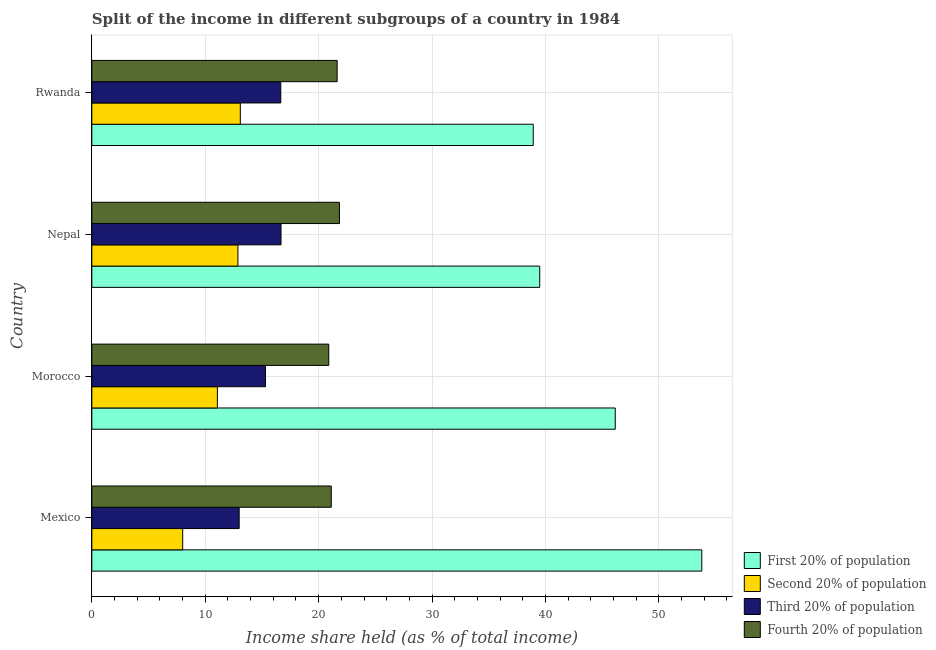Are the number of bars on each tick of the Y-axis equal?
Provide a short and direct response. Yes. How many bars are there on the 4th tick from the top?
Provide a succinct answer. 4. How many bars are there on the 2nd tick from the bottom?
Make the answer very short. 4. What is the label of the 1st group of bars from the top?
Give a very brief answer. Rwanda. In how many cases, is the number of bars for a given country not equal to the number of legend labels?
Offer a very short reply. 0. What is the share of the income held by third 20% of the population in Morocco?
Your answer should be compact. 15.31. Across all countries, what is the maximum share of the income held by second 20% of the population?
Keep it short and to the point. 13.09. Across all countries, what is the minimum share of the income held by third 20% of the population?
Provide a succinct answer. 12.99. In which country was the share of the income held by fourth 20% of the population maximum?
Your answer should be very brief. Nepal. What is the total share of the income held by fourth 20% of the population in the graph?
Offer a terse response. 85.46. What is the difference between the share of the income held by fourth 20% of the population in Mexico and that in Morocco?
Your answer should be very brief. 0.22. What is the difference between the share of the income held by third 20% of the population in Mexico and the share of the income held by first 20% of the population in Rwanda?
Offer a terse response. -25.93. What is the average share of the income held by second 20% of the population per country?
Make the answer very short. 11.26. What is the difference between the share of the income held by third 20% of the population and share of the income held by first 20% of the population in Mexico?
Offer a terse response. -40.79. What is the ratio of the share of the income held by fourth 20% of the population in Mexico to that in Nepal?
Offer a terse response. 0.97. What is the difference between the highest and the second highest share of the income held by second 20% of the population?
Your answer should be compact. 0.21. What is the difference between the highest and the lowest share of the income held by first 20% of the population?
Ensure brevity in your answer.  14.86. In how many countries, is the share of the income held by fourth 20% of the population greater than the average share of the income held by fourth 20% of the population taken over all countries?
Provide a succinct answer. 2. Is it the case that in every country, the sum of the share of the income held by third 20% of the population and share of the income held by second 20% of the population is greater than the sum of share of the income held by first 20% of the population and share of the income held by fourth 20% of the population?
Your answer should be compact. No. What does the 2nd bar from the top in Rwanda represents?
Provide a short and direct response. Third 20% of population. What does the 4th bar from the bottom in Mexico represents?
Your answer should be compact. Fourth 20% of population. Is it the case that in every country, the sum of the share of the income held by first 20% of the population and share of the income held by second 20% of the population is greater than the share of the income held by third 20% of the population?
Give a very brief answer. Yes. Are all the bars in the graph horizontal?
Your answer should be very brief. Yes. What is the difference between two consecutive major ticks on the X-axis?
Offer a very short reply. 10. Are the values on the major ticks of X-axis written in scientific E-notation?
Make the answer very short. No. Does the graph contain any zero values?
Give a very brief answer. No. Where does the legend appear in the graph?
Make the answer very short. Bottom right. How many legend labels are there?
Keep it short and to the point. 4. What is the title of the graph?
Make the answer very short. Split of the income in different subgroups of a country in 1984. What is the label or title of the X-axis?
Your answer should be very brief. Income share held (as % of total income). What is the label or title of the Y-axis?
Provide a short and direct response. Country. What is the Income share held (as % of total income) of First 20% of population in Mexico?
Your answer should be very brief. 53.78. What is the Income share held (as % of total income) in Second 20% of population in Mexico?
Provide a succinct answer. 8.01. What is the Income share held (as % of total income) of Third 20% of population in Mexico?
Keep it short and to the point. 12.99. What is the Income share held (as % of total income) in Fourth 20% of population in Mexico?
Provide a short and direct response. 21.11. What is the Income share held (as % of total income) of First 20% of population in Morocco?
Keep it short and to the point. 46.15. What is the Income share held (as % of total income) in Second 20% of population in Morocco?
Provide a succinct answer. 11.07. What is the Income share held (as % of total income) of Third 20% of population in Morocco?
Your response must be concise. 15.31. What is the Income share held (as % of total income) in Fourth 20% of population in Morocco?
Offer a terse response. 20.89. What is the Income share held (as % of total income) in First 20% of population in Nepal?
Provide a succinct answer. 39.49. What is the Income share held (as % of total income) in Second 20% of population in Nepal?
Your answer should be very brief. 12.88. What is the Income share held (as % of total income) of Third 20% of population in Nepal?
Offer a terse response. 16.68. What is the Income share held (as % of total income) in Fourth 20% of population in Nepal?
Provide a short and direct response. 21.83. What is the Income share held (as % of total income) in First 20% of population in Rwanda?
Your response must be concise. 38.92. What is the Income share held (as % of total income) in Second 20% of population in Rwanda?
Make the answer very short. 13.09. What is the Income share held (as % of total income) in Third 20% of population in Rwanda?
Keep it short and to the point. 16.66. What is the Income share held (as % of total income) of Fourth 20% of population in Rwanda?
Ensure brevity in your answer.  21.63. Across all countries, what is the maximum Income share held (as % of total income) of First 20% of population?
Your response must be concise. 53.78. Across all countries, what is the maximum Income share held (as % of total income) of Second 20% of population?
Offer a very short reply. 13.09. Across all countries, what is the maximum Income share held (as % of total income) of Third 20% of population?
Your answer should be very brief. 16.68. Across all countries, what is the maximum Income share held (as % of total income) in Fourth 20% of population?
Give a very brief answer. 21.83. Across all countries, what is the minimum Income share held (as % of total income) of First 20% of population?
Provide a short and direct response. 38.92. Across all countries, what is the minimum Income share held (as % of total income) in Second 20% of population?
Your answer should be very brief. 8.01. Across all countries, what is the minimum Income share held (as % of total income) of Third 20% of population?
Make the answer very short. 12.99. Across all countries, what is the minimum Income share held (as % of total income) of Fourth 20% of population?
Your answer should be compact. 20.89. What is the total Income share held (as % of total income) of First 20% of population in the graph?
Provide a short and direct response. 178.34. What is the total Income share held (as % of total income) of Second 20% of population in the graph?
Offer a very short reply. 45.05. What is the total Income share held (as % of total income) of Third 20% of population in the graph?
Your answer should be very brief. 61.64. What is the total Income share held (as % of total income) in Fourth 20% of population in the graph?
Ensure brevity in your answer.  85.46. What is the difference between the Income share held (as % of total income) of First 20% of population in Mexico and that in Morocco?
Offer a terse response. 7.63. What is the difference between the Income share held (as % of total income) in Second 20% of population in Mexico and that in Morocco?
Provide a succinct answer. -3.06. What is the difference between the Income share held (as % of total income) of Third 20% of population in Mexico and that in Morocco?
Make the answer very short. -2.32. What is the difference between the Income share held (as % of total income) of Fourth 20% of population in Mexico and that in Morocco?
Make the answer very short. 0.22. What is the difference between the Income share held (as % of total income) of First 20% of population in Mexico and that in Nepal?
Ensure brevity in your answer.  14.29. What is the difference between the Income share held (as % of total income) in Second 20% of population in Mexico and that in Nepal?
Offer a very short reply. -4.87. What is the difference between the Income share held (as % of total income) in Third 20% of population in Mexico and that in Nepal?
Your answer should be very brief. -3.69. What is the difference between the Income share held (as % of total income) of Fourth 20% of population in Mexico and that in Nepal?
Give a very brief answer. -0.72. What is the difference between the Income share held (as % of total income) of First 20% of population in Mexico and that in Rwanda?
Keep it short and to the point. 14.86. What is the difference between the Income share held (as % of total income) of Second 20% of population in Mexico and that in Rwanda?
Offer a very short reply. -5.08. What is the difference between the Income share held (as % of total income) in Third 20% of population in Mexico and that in Rwanda?
Offer a very short reply. -3.67. What is the difference between the Income share held (as % of total income) in Fourth 20% of population in Mexico and that in Rwanda?
Keep it short and to the point. -0.52. What is the difference between the Income share held (as % of total income) in First 20% of population in Morocco and that in Nepal?
Offer a terse response. 6.66. What is the difference between the Income share held (as % of total income) in Second 20% of population in Morocco and that in Nepal?
Make the answer very short. -1.81. What is the difference between the Income share held (as % of total income) in Third 20% of population in Morocco and that in Nepal?
Your answer should be very brief. -1.37. What is the difference between the Income share held (as % of total income) in Fourth 20% of population in Morocco and that in Nepal?
Give a very brief answer. -0.94. What is the difference between the Income share held (as % of total income) in First 20% of population in Morocco and that in Rwanda?
Make the answer very short. 7.23. What is the difference between the Income share held (as % of total income) in Second 20% of population in Morocco and that in Rwanda?
Your response must be concise. -2.02. What is the difference between the Income share held (as % of total income) of Third 20% of population in Morocco and that in Rwanda?
Keep it short and to the point. -1.35. What is the difference between the Income share held (as % of total income) of Fourth 20% of population in Morocco and that in Rwanda?
Offer a terse response. -0.74. What is the difference between the Income share held (as % of total income) in First 20% of population in Nepal and that in Rwanda?
Offer a terse response. 0.57. What is the difference between the Income share held (as % of total income) in Second 20% of population in Nepal and that in Rwanda?
Make the answer very short. -0.21. What is the difference between the Income share held (as % of total income) in Third 20% of population in Nepal and that in Rwanda?
Offer a terse response. 0.02. What is the difference between the Income share held (as % of total income) in First 20% of population in Mexico and the Income share held (as % of total income) in Second 20% of population in Morocco?
Keep it short and to the point. 42.71. What is the difference between the Income share held (as % of total income) of First 20% of population in Mexico and the Income share held (as % of total income) of Third 20% of population in Morocco?
Offer a very short reply. 38.47. What is the difference between the Income share held (as % of total income) in First 20% of population in Mexico and the Income share held (as % of total income) in Fourth 20% of population in Morocco?
Offer a terse response. 32.89. What is the difference between the Income share held (as % of total income) of Second 20% of population in Mexico and the Income share held (as % of total income) of Third 20% of population in Morocco?
Your answer should be very brief. -7.3. What is the difference between the Income share held (as % of total income) in Second 20% of population in Mexico and the Income share held (as % of total income) in Fourth 20% of population in Morocco?
Offer a terse response. -12.88. What is the difference between the Income share held (as % of total income) in Third 20% of population in Mexico and the Income share held (as % of total income) in Fourth 20% of population in Morocco?
Your answer should be very brief. -7.9. What is the difference between the Income share held (as % of total income) in First 20% of population in Mexico and the Income share held (as % of total income) in Second 20% of population in Nepal?
Keep it short and to the point. 40.9. What is the difference between the Income share held (as % of total income) in First 20% of population in Mexico and the Income share held (as % of total income) in Third 20% of population in Nepal?
Provide a short and direct response. 37.1. What is the difference between the Income share held (as % of total income) of First 20% of population in Mexico and the Income share held (as % of total income) of Fourth 20% of population in Nepal?
Your response must be concise. 31.95. What is the difference between the Income share held (as % of total income) of Second 20% of population in Mexico and the Income share held (as % of total income) of Third 20% of population in Nepal?
Provide a short and direct response. -8.67. What is the difference between the Income share held (as % of total income) in Second 20% of population in Mexico and the Income share held (as % of total income) in Fourth 20% of population in Nepal?
Make the answer very short. -13.82. What is the difference between the Income share held (as % of total income) of Third 20% of population in Mexico and the Income share held (as % of total income) of Fourth 20% of population in Nepal?
Offer a very short reply. -8.84. What is the difference between the Income share held (as % of total income) of First 20% of population in Mexico and the Income share held (as % of total income) of Second 20% of population in Rwanda?
Give a very brief answer. 40.69. What is the difference between the Income share held (as % of total income) in First 20% of population in Mexico and the Income share held (as % of total income) in Third 20% of population in Rwanda?
Your answer should be compact. 37.12. What is the difference between the Income share held (as % of total income) in First 20% of population in Mexico and the Income share held (as % of total income) in Fourth 20% of population in Rwanda?
Provide a succinct answer. 32.15. What is the difference between the Income share held (as % of total income) in Second 20% of population in Mexico and the Income share held (as % of total income) in Third 20% of population in Rwanda?
Make the answer very short. -8.65. What is the difference between the Income share held (as % of total income) of Second 20% of population in Mexico and the Income share held (as % of total income) of Fourth 20% of population in Rwanda?
Your answer should be compact. -13.62. What is the difference between the Income share held (as % of total income) in Third 20% of population in Mexico and the Income share held (as % of total income) in Fourth 20% of population in Rwanda?
Give a very brief answer. -8.64. What is the difference between the Income share held (as % of total income) of First 20% of population in Morocco and the Income share held (as % of total income) of Second 20% of population in Nepal?
Ensure brevity in your answer.  33.27. What is the difference between the Income share held (as % of total income) in First 20% of population in Morocco and the Income share held (as % of total income) in Third 20% of population in Nepal?
Offer a terse response. 29.47. What is the difference between the Income share held (as % of total income) of First 20% of population in Morocco and the Income share held (as % of total income) of Fourth 20% of population in Nepal?
Keep it short and to the point. 24.32. What is the difference between the Income share held (as % of total income) of Second 20% of population in Morocco and the Income share held (as % of total income) of Third 20% of population in Nepal?
Give a very brief answer. -5.61. What is the difference between the Income share held (as % of total income) in Second 20% of population in Morocco and the Income share held (as % of total income) in Fourth 20% of population in Nepal?
Offer a very short reply. -10.76. What is the difference between the Income share held (as % of total income) in Third 20% of population in Morocco and the Income share held (as % of total income) in Fourth 20% of population in Nepal?
Offer a very short reply. -6.52. What is the difference between the Income share held (as % of total income) in First 20% of population in Morocco and the Income share held (as % of total income) in Second 20% of population in Rwanda?
Provide a short and direct response. 33.06. What is the difference between the Income share held (as % of total income) of First 20% of population in Morocco and the Income share held (as % of total income) of Third 20% of population in Rwanda?
Keep it short and to the point. 29.49. What is the difference between the Income share held (as % of total income) in First 20% of population in Morocco and the Income share held (as % of total income) in Fourth 20% of population in Rwanda?
Your answer should be compact. 24.52. What is the difference between the Income share held (as % of total income) in Second 20% of population in Morocco and the Income share held (as % of total income) in Third 20% of population in Rwanda?
Your answer should be compact. -5.59. What is the difference between the Income share held (as % of total income) in Second 20% of population in Morocco and the Income share held (as % of total income) in Fourth 20% of population in Rwanda?
Keep it short and to the point. -10.56. What is the difference between the Income share held (as % of total income) of Third 20% of population in Morocco and the Income share held (as % of total income) of Fourth 20% of population in Rwanda?
Provide a short and direct response. -6.32. What is the difference between the Income share held (as % of total income) of First 20% of population in Nepal and the Income share held (as % of total income) of Second 20% of population in Rwanda?
Provide a succinct answer. 26.4. What is the difference between the Income share held (as % of total income) of First 20% of population in Nepal and the Income share held (as % of total income) of Third 20% of population in Rwanda?
Ensure brevity in your answer.  22.83. What is the difference between the Income share held (as % of total income) in First 20% of population in Nepal and the Income share held (as % of total income) in Fourth 20% of population in Rwanda?
Offer a very short reply. 17.86. What is the difference between the Income share held (as % of total income) in Second 20% of population in Nepal and the Income share held (as % of total income) in Third 20% of population in Rwanda?
Your answer should be compact. -3.78. What is the difference between the Income share held (as % of total income) in Second 20% of population in Nepal and the Income share held (as % of total income) in Fourth 20% of population in Rwanda?
Your answer should be compact. -8.75. What is the difference between the Income share held (as % of total income) of Third 20% of population in Nepal and the Income share held (as % of total income) of Fourth 20% of population in Rwanda?
Provide a succinct answer. -4.95. What is the average Income share held (as % of total income) of First 20% of population per country?
Keep it short and to the point. 44.59. What is the average Income share held (as % of total income) in Second 20% of population per country?
Your response must be concise. 11.26. What is the average Income share held (as % of total income) in Third 20% of population per country?
Offer a terse response. 15.41. What is the average Income share held (as % of total income) in Fourth 20% of population per country?
Offer a very short reply. 21.36. What is the difference between the Income share held (as % of total income) in First 20% of population and Income share held (as % of total income) in Second 20% of population in Mexico?
Your answer should be compact. 45.77. What is the difference between the Income share held (as % of total income) of First 20% of population and Income share held (as % of total income) of Third 20% of population in Mexico?
Give a very brief answer. 40.79. What is the difference between the Income share held (as % of total income) in First 20% of population and Income share held (as % of total income) in Fourth 20% of population in Mexico?
Provide a short and direct response. 32.67. What is the difference between the Income share held (as % of total income) in Second 20% of population and Income share held (as % of total income) in Third 20% of population in Mexico?
Give a very brief answer. -4.98. What is the difference between the Income share held (as % of total income) of Third 20% of population and Income share held (as % of total income) of Fourth 20% of population in Mexico?
Give a very brief answer. -8.12. What is the difference between the Income share held (as % of total income) in First 20% of population and Income share held (as % of total income) in Second 20% of population in Morocco?
Keep it short and to the point. 35.08. What is the difference between the Income share held (as % of total income) of First 20% of population and Income share held (as % of total income) of Third 20% of population in Morocco?
Keep it short and to the point. 30.84. What is the difference between the Income share held (as % of total income) of First 20% of population and Income share held (as % of total income) of Fourth 20% of population in Morocco?
Give a very brief answer. 25.26. What is the difference between the Income share held (as % of total income) in Second 20% of population and Income share held (as % of total income) in Third 20% of population in Morocco?
Offer a very short reply. -4.24. What is the difference between the Income share held (as % of total income) of Second 20% of population and Income share held (as % of total income) of Fourth 20% of population in Morocco?
Provide a short and direct response. -9.82. What is the difference between the Income share held (as % of total income) in Third 20% of population and Income share held (as % of total income) in Fourth 20% of population in Morocco?
Ensure brevity in your answer.  -5.58. What is the difference between the Income share held (as % of total income) in First 20% of population and Income share held (as % of total income) in Second 20% of population in Nepal?
Keep it short and to the point. 26.61. What is the difference between the Income share held (as % of total income) of First 20% of population and Income share held (as % of total income) of Third 20% of population in Nepal?
Ensure brevity in your answer.  22.81. What is the difference between the Income share held (as % of total income) in First 20% of population and Income share held (as % of total income) in Fourth 20% of population in Nepal?
Provide a short and direct response. 17.66. What is the difference between the Income share held (as % of total income) of Second 20% of population and Income share held (as % of total income) of Fourth 20% of population in Nepal?
Your answer should be very brief. -8.95. What is the difference between the Income share held (as % of total income) of Third 20% of population and Income share held (as % of total income) of Fourth 20% of population in Nepal?
Keep it short and to the point. -5.15. What is the difference between the Income share held (as % of total income) of First 20% of population and Income share held (as % of total income) of Second 20% of population in Rwanda?
Make the answer very short. 25.83. What is the difference between the Income share held (as % of total income) in First 20% of population and Income share held (as % of total income) in Third 20% of population in Rwanda?
Give a very brief answer. 22.26. What is the difference between the Income share held (as % of total income) of First 20% of population and Income share held (as % of total income) of Fourth 20% of population in Rwanda?
Offer a terse response. 17.29. What is the difference between the Income share held (as % of total income) in Second 20% of population and Income share held (as % of total income) in Third 20% of population in Rwanda?
Give a very brief answer. -3.57. What is the difference between the Income share held (as % of total income) of Second 20% of population and Income share held (as % of total income) of Fourth 20% of population in Rwanda?
Provide a short and direct response. -8.54. What is the difference between the Income share held (as % of total income) of Third 20% of population and Income share held (as % of total income) of Fourth 20% of population in Rwanda?
Keep it short and to the point. -4.97. What is the ratio of the Income share held (as % of total income) in First 20% of population in Mexico to that in Morocco?
Make the answer very short. 1.17. What is the ratio of the Income share held (as % of total income) of Second 20% of population in Mexico to that in Morocco?
Your answer should be compact. 0.72. What is the ratio of the Income share held (as % of total income) in Third 20% of population in Mexico to that in Morocco?
Give a very brief answer. 0.85. What is the ratio of the Income share held (as % of total income) in Fourth 20% of population in Mexico to that in Morocco?
Your answer should be compact. 1.01. What is the ratio of the Income share held (as % of total income) of First 20% of population in Mexico to that in Nepal?
Your answer should be compact. 1.36. What is the ratio of the Income share held (as % of total income) of Second 20% of population in Mexico to that in Nepal?
Give a very brief answer. 0.62. What is the ratio of the Income share held (as % of total income) of Third 20% of population in Mexico to that in Nepal?
Offer a very short reply. 0.78. What is the ratio of the Income share held (as % of total income) of Fourth 20% of population in Mexico to that in Nepal?
Ensure brevity in your answer.  0.97. What is the ratio of the Income share held (as % of total income) in First 20% of population in Mexico to that in Rwanda?
Provide a succinct answer. 1.38. What is the ratio of the Income share held (as % of total income) of Second 20% of population in Mexico to that in Rwanda?
Give a very brief answer. 0.61. What is the ratio of the Income share held (as % of total income) of Third 20% of population in Mexico to that in Rwanda?
Provide a short and direct response. 0.78. What is the ratio of the Income share held (as % of total income) of Fourth 20% of population in Mexico to that in Rwanda?
Provide a short and direct response. 0.98. What is the ratio of the Income share held (as % of total income) of First 20% of population in Morocco to that in Nepal?
Offer a terse response. 1.17. What is the ratio of the Income share held (as % of total income) of Second 20% of population in Morocco to that in Nepal?
Offer a very short reply. 0.86. What is the ratio of the Income share held (as % of total income) in Third 20% of population in Morocco to that in Nepal?
Give a very brief answer. 0.92. What is the ratio of the Income share held (as % of total income) in Fourth 20% of population in Morocco to that in Nepal?
Offer a terse response. 0.96. What is the ratio of the Income share held (as % of total income) of First 20% of population in Morocco to that in Rwanda?
Provide a short and direct response. 1.19. What is the ratio of the Income share held (as % of total income) in Second 20% of population in Morocco to that in Rwanda?
Make the answer very short. 0.85. What is the ratio of the Income share held (as % of total income) of Third 20% of population in Morocco to that in Rwanda?
Give a very brief answer. 0.92. What is the ratio of the Income share held (as % of total income) in Fourth 20% of population in Morocco to that in Rwanda?
Give a very brief answer. 0.97. What is the ratio of the Income share held (as % of total income) of First 20% of population in Nepal to that in Rwanda?
Keep it short and to the point. 1.01. What is the ratio of the Income share held (as % of total income) of Third 20% of population in Nepal to that in Rwanda?
Give a very brief answer. 1. What is the ratio of the Income share held (as % of total income) in Fourth 20% of population in Nepal to that in Rwanda?
Your response must be concise. 1.01. What is the difference between the highest and the second highest Income share held (as % of total income) of First 20% of population?
Offer a terse response. 7.63. What is the difference between the highest and the second highest Income share held (as % of total income) in Second 20% of population?
Your response must be concise. 0.21. What is the difference between the highest and the second highest Income share held (as % of total income) of Third 20% of population?
Provide a short and direct response. 0.02. What is the difference between the highest and the lowest Income share held (as % of total income) in First 20% of population?
Provide a short and direct response. 14.86. What is the difference between the highest and the lowest Income share held (as % of total income) in Second 20% of population?
Keep it short and to the point. 5.08. What is the difference between the highest and the lowest Income share held (as % of total income) of Third 20% of population?
Give a very brief answer. 3.69. What is the difference between the highest and the lowest Income share held (as % of total income) of Fourth 20% of population?
Your answer should be very brief. 0.94. 